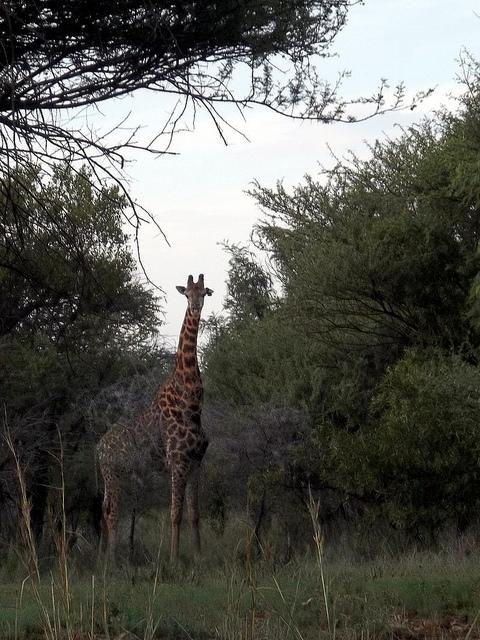How many animals are standing in the forest?
Concise answer only. 1. Is this animal prehistoric?
Quick response, please. No. Is this animal facing the camera?
Give a very brief answer. Yes. How many animals?
Be succinct. 1. Is it sunny?
Keep it brief. No. What is the weather like?
Concise answer only. Sunny. Is the giraffe in the wild?
Be succinct. Yes. What animal is this?
Concise answer only. Giraffe. 